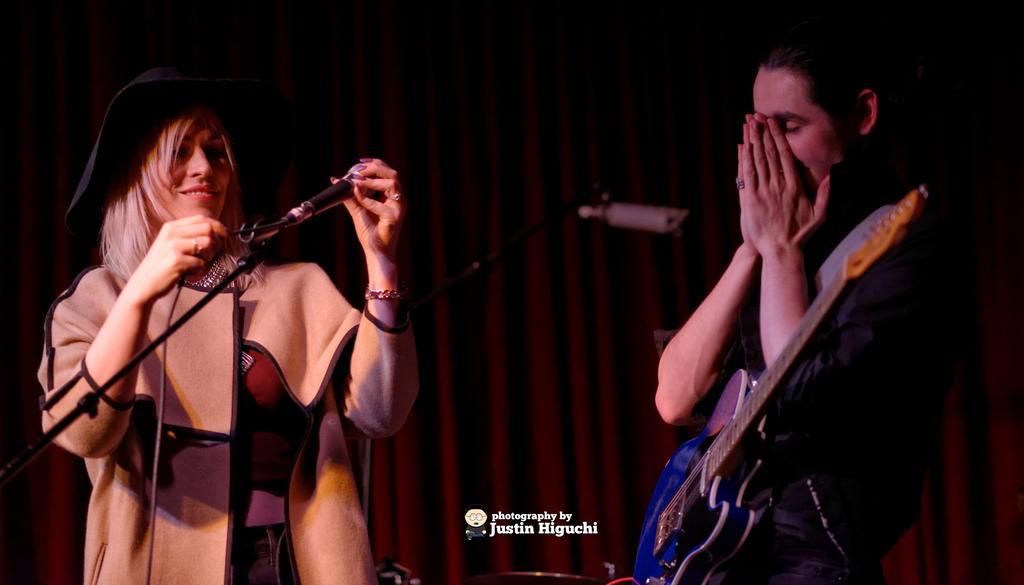Please provide a concise description of this image. In this picture there is a woman and a man standing. The woman is smiling and she is holding a mic in her hand. The woman is wearing a coat. The man is holding a guitar across his shoulders. In the background there is a red color curtain. 